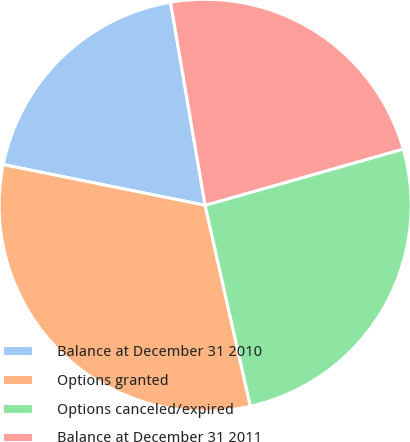<chart> <loc_0><loc_0><loc_500><loc_500><pie_chart><fcel>Balance at December 31 2010<fcel>Options granted<fcel>Options canceled/expired<fcel>Balance at December 31 2011<nl><fcel>19.15%<fcel>31.69%<fcel>25.88%<fcel>23.28%<nl></chart> 